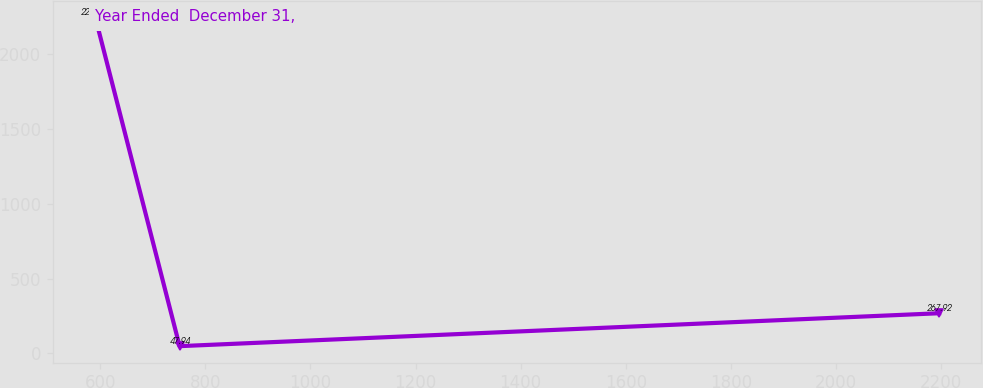Convert chart to OTSL. <chart><loc_0><loc_0><loc_500><loc_500><line_chart><ecel><fcel>Year Ended  December 31,<nl><fcel>590.54<fcel>2247.71<nl><fcel>751.1<fcel>47.94<nl><fcel>2196.12<fcel>267.92<nl></chart> 